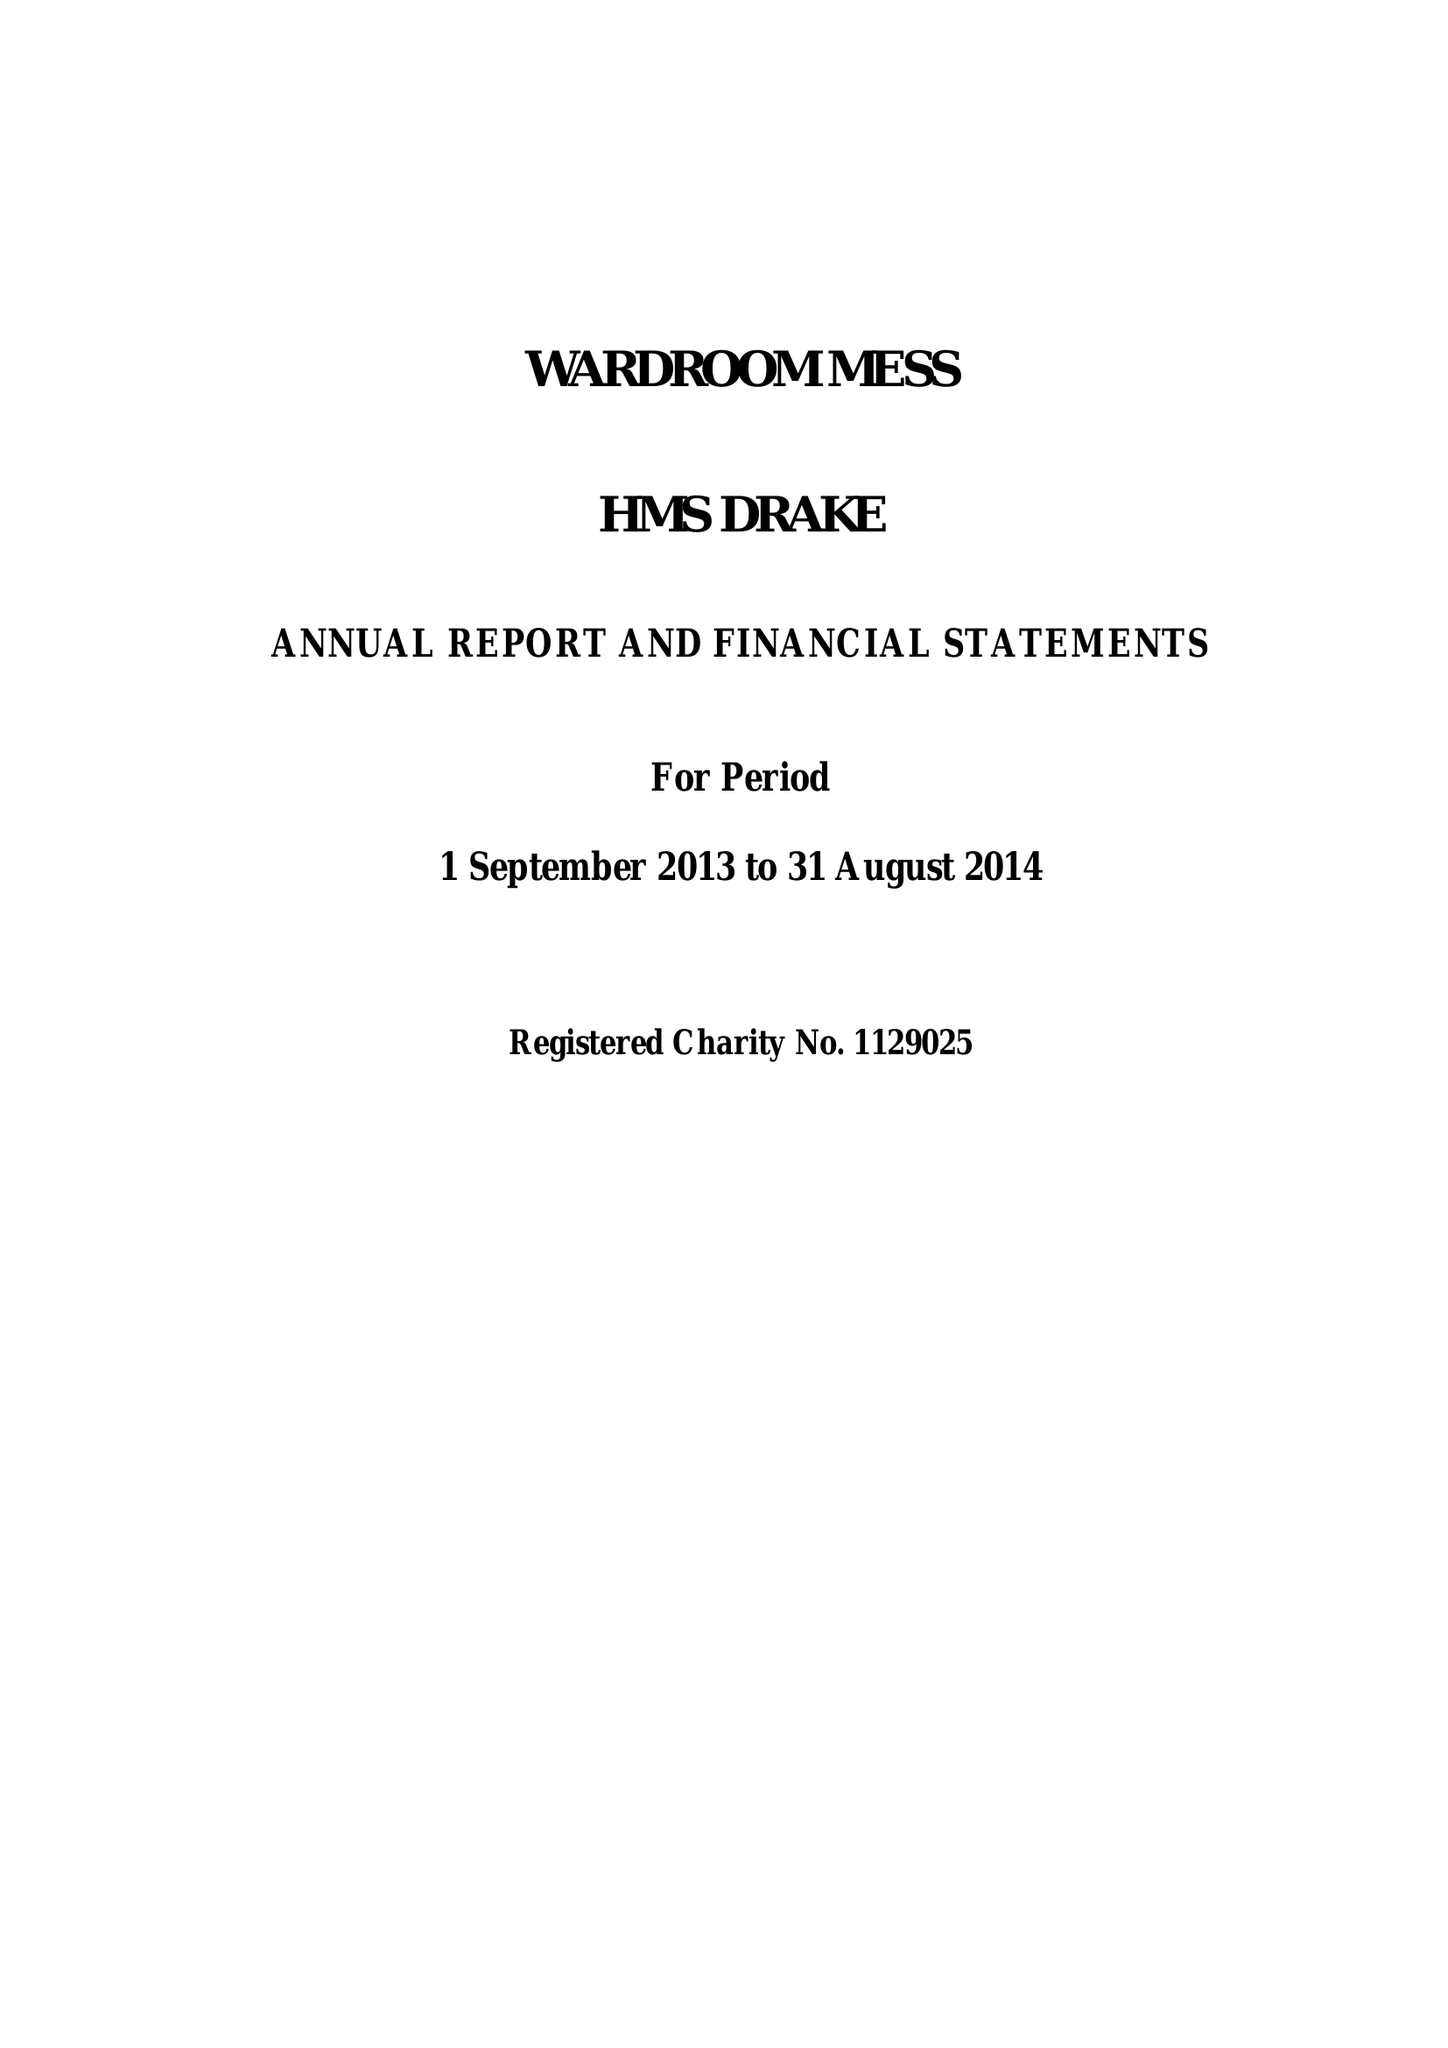What is the value for the report_date?
Answer the question using a single word or phrase. 2014-08-31 